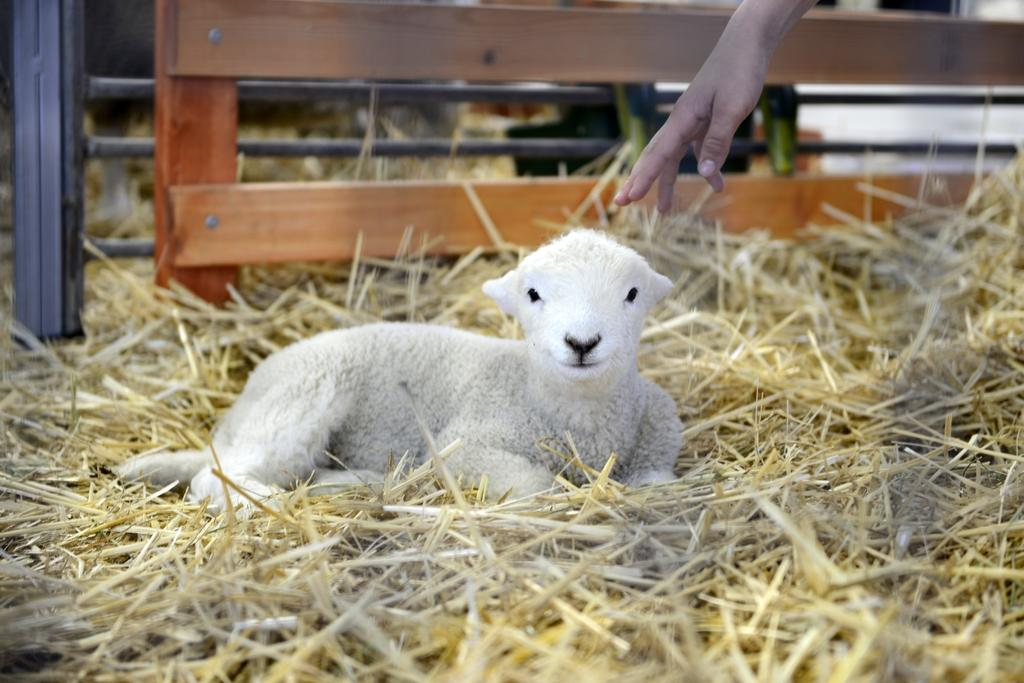What part of a person can be seen in the image? There is a person's hand in the image. What type of animal is present in the image? There is a baby sheep in the image. What is the baby sheep sitting on? The baby sheep is sitting on dry grass. What type of agreement is the monkey holding in the image? There is no monkey present in the image, and therefore no agreement can be observed. What is the baby sheep using to pull the yoke in the image? There is no yoke present in the image, and the baby sheep is not pulling anything. 